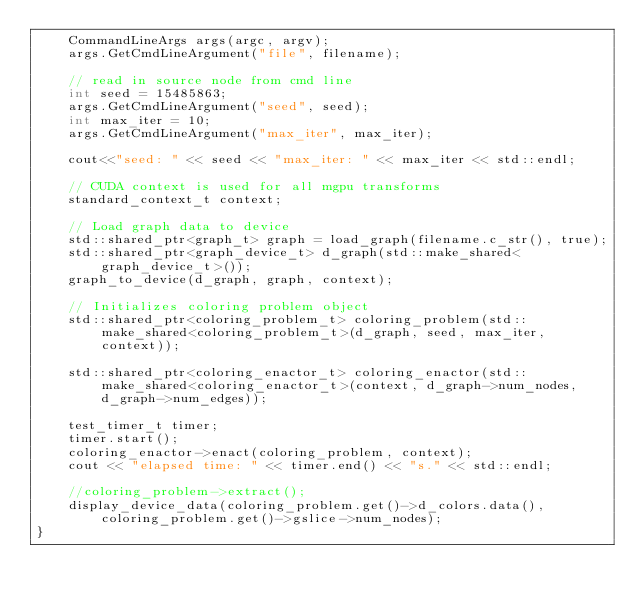Convert code to text. <code><loc_0><loc_0><loc_500><loc_500><_Cuda_>    CommandLineArgs args(argc, argv);
    args.GetCmdLineArgument("file", filename);

    // read in source node from cmd line
    int seed = 15485863;
    args.GetCmdLineArgument("seed", seed);
    int max_iter = 10;
    args.GetCmdLineArgument("max_iter", max_iter);

    cout<<"seed: " << seed << "max_iter: " << max_iter << std::endl;

    // CUDA context is used for all mgpu transforms
    standard_context_t context;
   
    // Load graph data to device
    std::shared_ptr<graph_t> graph = load_graph(filename.c_str(), true);
    std::shared_ptr<graph_device_t> d_graph(std::make_shared<graph_device_t>());
    graph_to_device(d_graph, graph, context);

    // Initializes coloring problem object
    std::shared_ptr<coloring_problem_t> coloring_problem(std::make_shared<coloring_problem_t>(d_graph, seed, max_iter, context));

    std::shared_ptr<coloring_enactor_t> coloring_enactor(std::make_shared<coloring_enactor_t>(context, d_graph->num_nodes, d_graph->num_edges));

    test_timer_t timer;
    timer.start();
    coloring_enactor->enact(coloring_problem, context);
    cout << "elapsed time: " << timer.end() << "s." << std::endl;

    //coloring_problem->extract();
    display_device_data(coloring_problem.get()->d_colors.data(), coloring_problem.get()->gslice->num_nodes);
}



</code> 